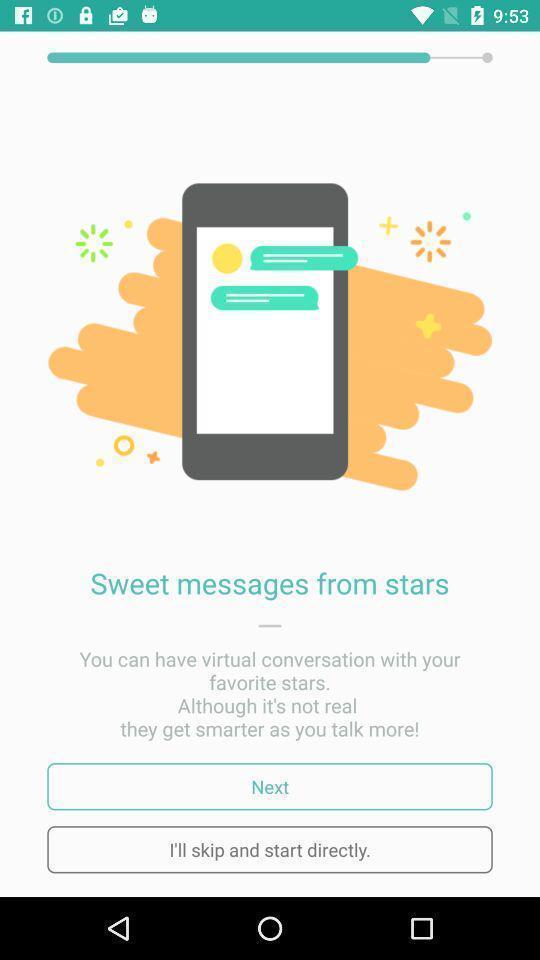Please provide a description for this image. Welcome page for a new app. 